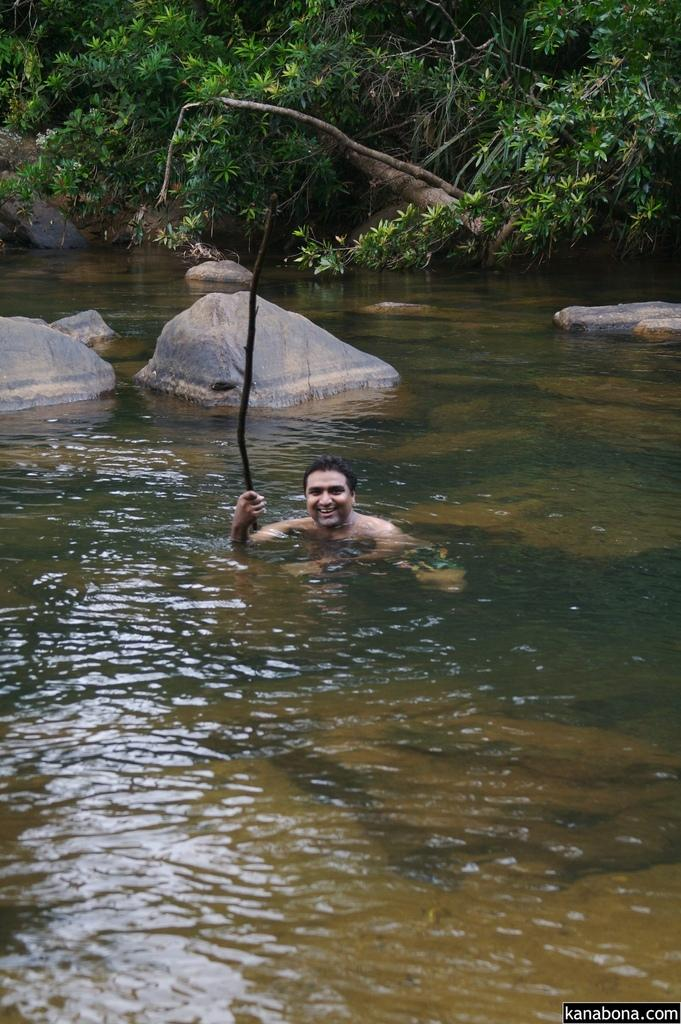What is the person in the image doing? The person is in the water. What can be seen in the background of the image? There are trees and rocks in the background of the image. Is there any text or logo visible on the image? Yes, the image has a watermark. How many ants can be seen carrying a cup in the image? There are no ants or cups present in the image. What type of maid is attending to the person in the water? There is no maid present in the image. 